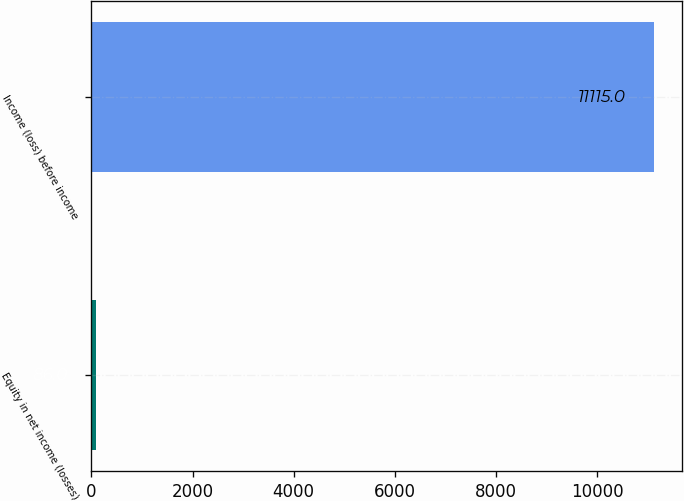<chart> <loc_0><loc_0><loc_500><loc_500><bar_chart><fcel>Equity in net income (losses)<fcel>Income (loss) before income<nl><fcel>86<fcel>11115<nl></chart> 